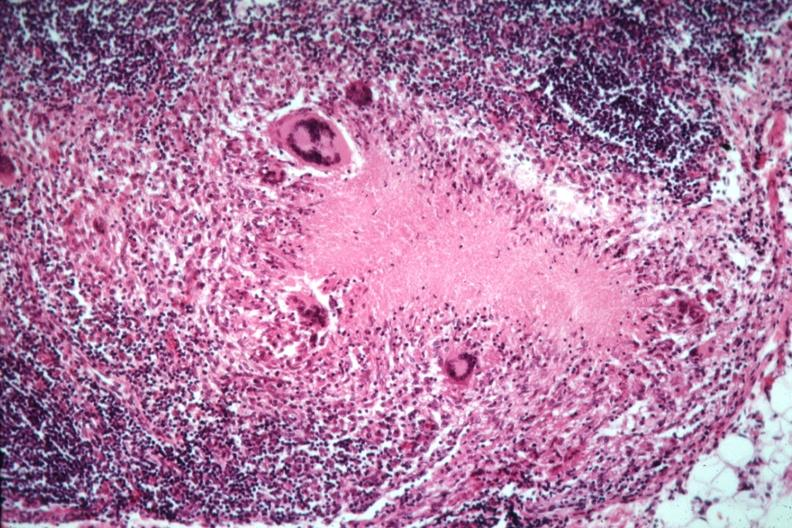what is present?
Answer the question using a single word or phrase. Lymph node 